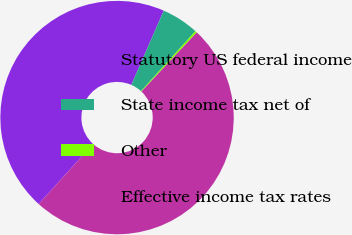Convert chart to OTSL. <chart><loc_0><loc_0><loc_500><loc_500><pie_chart><fcel>Statutory US federal income<fcel>State income tax net of<fcel>Other<fcel>Effective income tax rates<nl><fcel>44.84%<fcel>5.16%<fcel>0.26%<fcel>49.74%<nl></chart> 